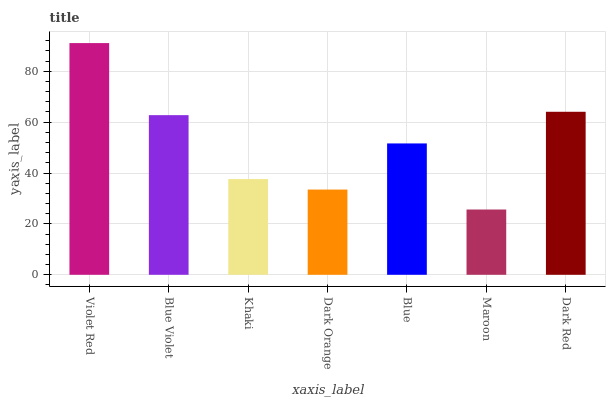Is Maroon the minimum?
Answer yes or no. Yes. Is Violet Red the maximum?
Answer yes or no. Yes. Is Blue Violet the minimum?
Answer yes or no. No. Is Blue Violet the maximum?
Answer yes or no. No. Is Violet Red greater than Blue Violet?
Answer yes or no. Yes. Is Blue Violet less than Violet Red?
Answer yes or no. Yes. Is Blue Violet greater than Violet Red?
Answer yes or no. No. Is Violet Red less than Blue Violet?
Answer yes or no. No. Is Blue the high median?
Answer yes or no. Yes. Is Blue the low median?
Answer yes or no. Yes. Is Blue Violet the high median?
Answer yes or no. No. Is Dark Red the low median?
Answer yes or no. No. 